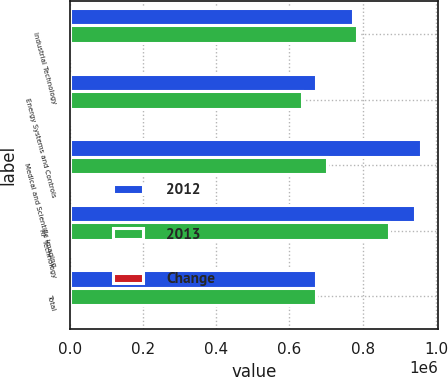Convert chart to OTSL. <chart><loc_0><loc_0><loc_500><loc_500><stacked_bar_chart><ecel><fcel>Industrial Technology<fcel>Energy Systems and Controls<fcel>Medical and Scientific Imaging<fcel>RF Technology<fcel>Total<nl><fcel>2012<fcel>772337<fcel>673569<fcel>958830<fcel>943757<fcel>673569<nl><fcel>2013<fcel>783362<fcel>634051<fcel>703034<fcel>871225<fcel>673569<nl><fcel>Change<fcel>1.4<fcel>6.2<fcel>36.4<fcel>8.3<fcel>11.9<nl></chart> 